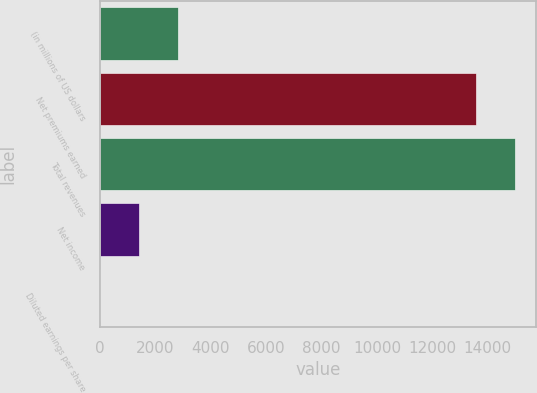Convert chart. <chart><loc_0><loc_0><loc_500><loc_500><bar_chart><fcel>(in millions of US dollars<fcel>Net premiums earned<fcel>Total revenues<fcel>Net income<fcel>Diluted earnings per share<nl><fcel>2815.7<fcel>13596<fcel>15002<fcel>1409.66<fcel>3.62<nl></chart> 